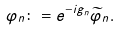Convert formula to latex. <formula><loc_0><loc_0><loc_500><loc_500>\varphi _ { n } \colon = e ^ { - i g _ { n } } \widetilde { \varphi } _ { n } .</formula> 